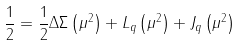<formula> <loc_0><loc_0><loc_500><loc_500>\frac { 1 } { 2 } = \frac { 1 } { 2 } \Delta \Sigma \left ( \mu ^ { 2 } \right ) + L _ { q } \left ( \mu ^ { 2 } \right ) + J _ { q } \left ( \mu ^ { 2 } \right )</formula> 